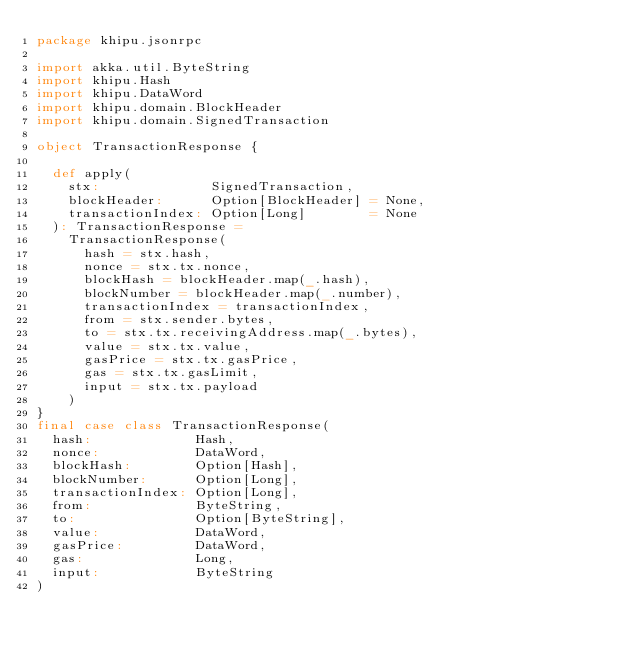Convert code to text. <code><loc_0><loc_0><loc_500><loc_500><_Scala_>package khipu.jsonrpc

import akka.util.ByteString
import khipu.Hash
import khipu.DataWord
import khipu.domain.BlockHeader
import khipu.domain.SignedTransaction

object TransactionResponse {

  def apply(
    stx:              SignedTransaction,
    blockHeader:      Option[BlockHeader] = None,
    transactionIndex: Option[Long]        = None
  ): TransactionResponse =
    TransactionResponse(
      hash = stx.hash,
      nonce = stx.tx.nonce,
      blockHash = blockHeader.map(_.hash),
      blockNumber = blockHeader.map(_.number),
      transactionIndex = transactionIndex,
      from = stx.sender.bytes,
      to = stx.tx.receivingAddress.map(_.bytes),
      value = stx.tx.value,
      gasPrice = stx.tx.gasPrice,
      gas = stx.tx.gasLimit,
      input = stx.tx.payload
    )
}
final case class TransactionResponse(
  hash:             Hash,
  nonce:            DataWord,
  blockHash:        Option[Hash],
  blockNumber:      Option[Long],
  transactionIndex: Option[Long],
  from:             ByteString,
  to:               Option[ByteString],
  value:            DataWord,
  gasPrice:         DataWord,
  gas:              Long,
  input:            ByteString
)

</code> 